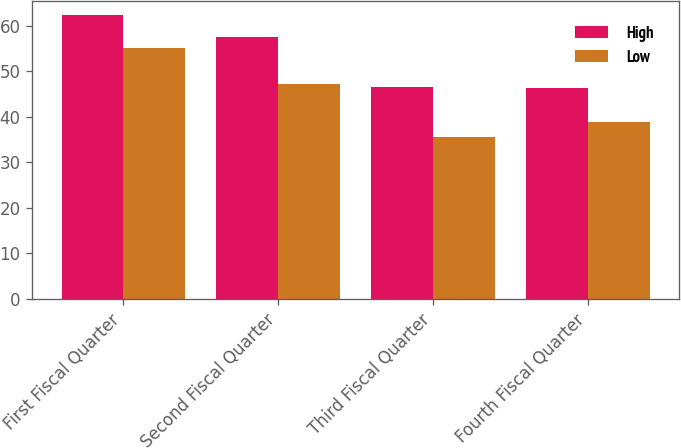<chart> <loc_0><loc_0><loc_500><loc_500><stacked_bar_chart><ecel><fcel>First Fiscal Quarter<fcel>Second Fiscal Quarter<fcel>Third Fiscal Quarter<fcel>Fourth Fiscal Quarter<nl><fcel>High<fcel>62.46<fcel>57.54<fcel>46.54<fcel>46.27<nl><fcel>Low<fcel>55.1<fcel>47.19<fcel>35.61<fcel>38.91<nl></chart> 